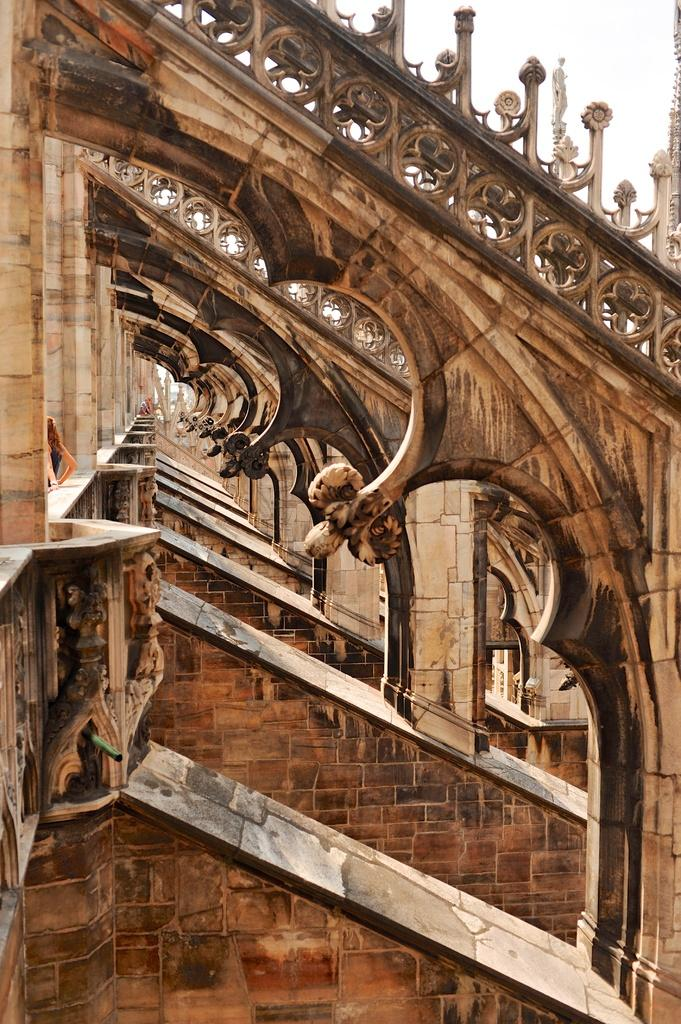What type of building is depicted in the image? There is an old architecture building in the image. What type of bottle is dad holding in the image? There is no dad or bottle present in the image; it only features an old architecture building. 